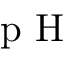Convert formula to latex. <formula><loc_0><loc_0><loc_500><loc_500>p H</formula> 